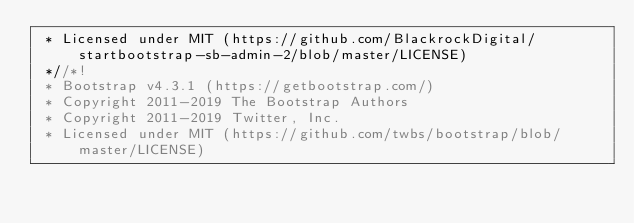Convert code to text. <code><loc_0><loc_0><loc_500><loc_500><_CSS_> * Licensed under MIT (https://github.com/BlackrockDigital/startbootstrap-sb-admin-2/blob/master/LICENSE)
 *//*!
 * Bootstrap v4.3.1 (https://getbootstrap.com/)
 * Copyright 2011-2019 The Bootstrap Authors
 * Copyright 2011-2019 Twitter, Inc.
 * Licensed under MIT (https://github.com/twbs/bootstrap/blob/master/LICENSE)</code> 